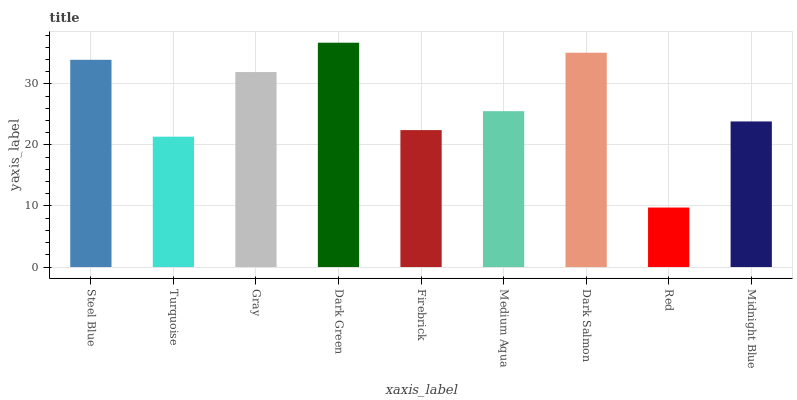Is Red the minimum?
Answer yes or no. Yes. Is Dark Green the maximum?
Answer yes or no. Yes. Is Turquoise the minimum?
Answer yes or no. No. Is Turquoise the maximum?
Answer yes or no. No. Is Steel Blue greater than Turquoise?
Answer yes or no. Yes. Is Turquoise less than Steel Blue?
Answer yes or no. Yes. Is Turquoise greater than Steel Blue?
Answer yes or no. No. Is Steel Blue less than Turquoise?
Answer yes or no. No. Is Medium Aqua the high median?
Answer yes or no. Yes. Is Medium Aqua the low median?
Answer yes or no. Yes. Is Dark Salmon the high median?
Answer yes or no. No. Is Firebrick the low median?
Answer yes or no. No. 